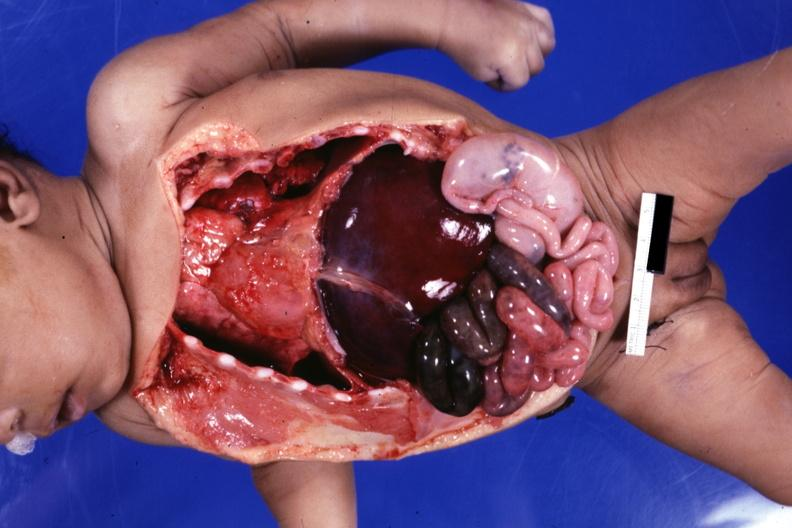what is infant body opened?
Answer the question using a single word or phrase. Showing cardiac apex to right, right liver lobe on left cecum on left gangrenous small bowel 